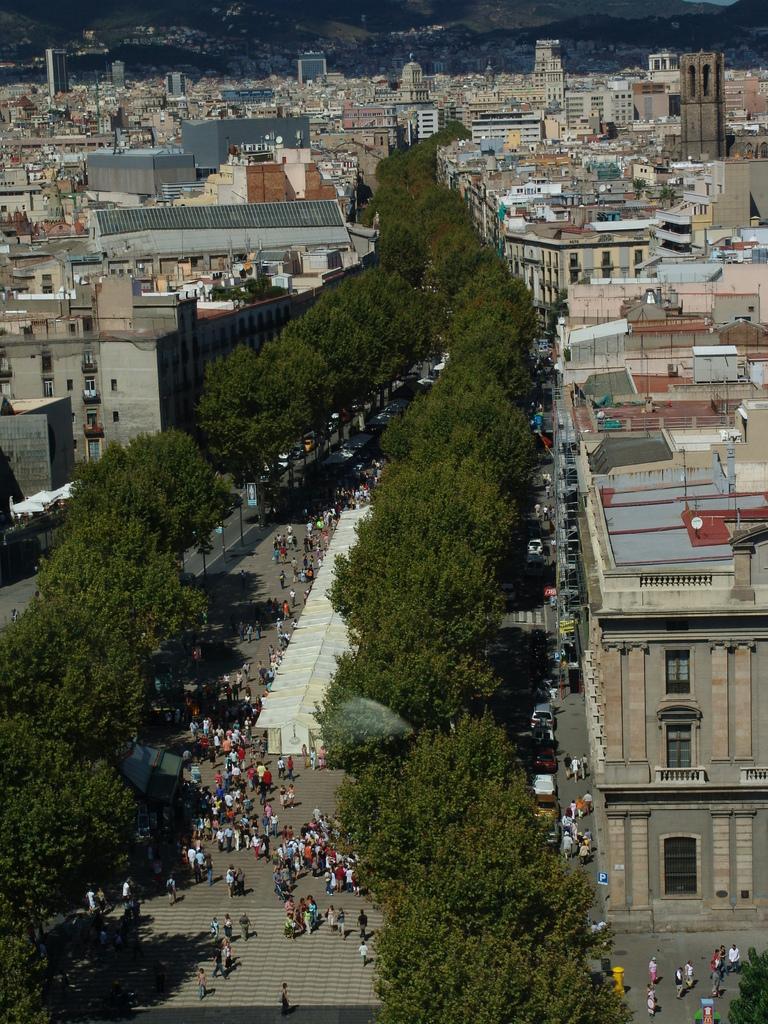Can you describe this image briefly? In this picture we can see buildings, trees, boards, vehicles and people. 